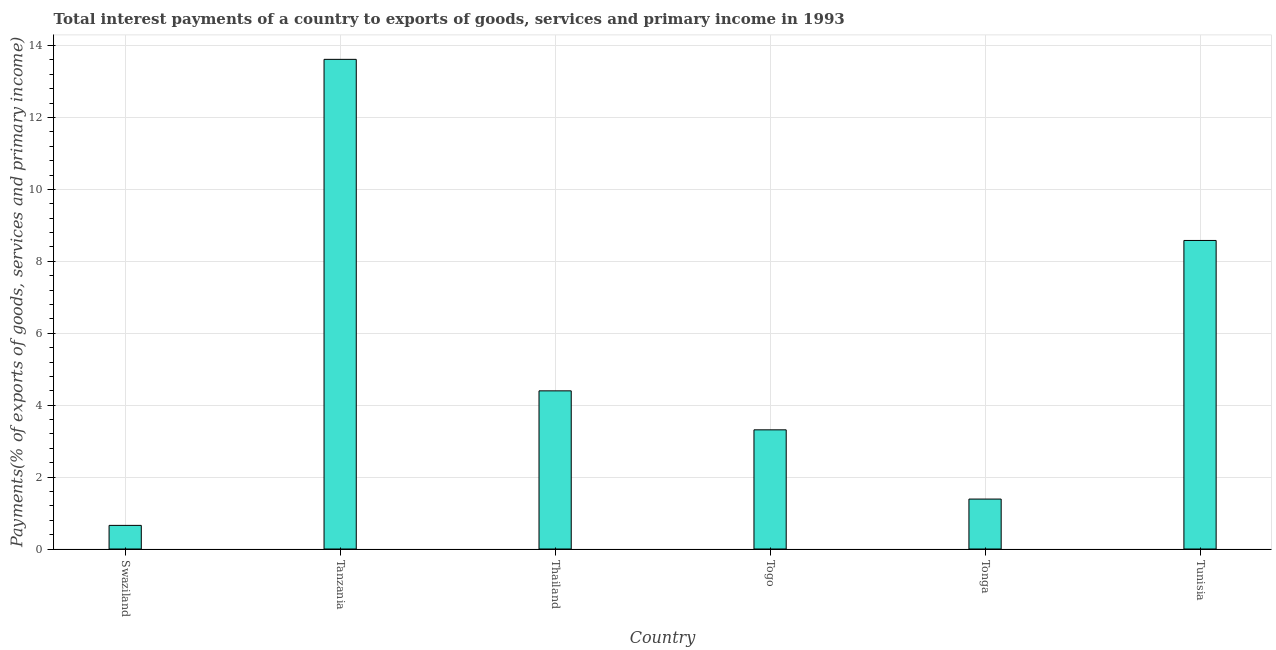Does the graph contain grids?
Keep it short and to the point. Yes. What is the title of the graph?
Offer a very short reply. Total interest payments of a country to exports of goods, services and primary income in 1993. What is the label or title of the X-axis?
Make the answer very short. Country. What is the label or title of the Y-axis?
Offer a very short reply. Payments(% of exports of goods, services and primary income). What is the total interest payments on external debt in Tanzania?
Keep it short and to the point. 13.62. Across all countries, what is the maximum total interest payments on external debt?
Provide a short and direct response. 13.62. Across all countries, what is the minimum total interest payments on external debt?
Ensure brevity in your answer.  0.66. In which country was the total interest payments on external debt maximum?
Offer a very short reply. Tanzania. In which country was the total interest payments on external debt minimum?
Make the answer very short. Swaziland. What is the sum of the total interest payments on external debt?
Your answer should be compact. 31.96. What is the difference between the total interest payments on external debt in Togo and Tonga?
Offer a very short reply. 1.93. What is the average total interest payments on external debt per country?
Give a very brief answer. 5.33. What is the median total interest payments on external debt?
Give a very brief answer. 3.86. What is the ratio of the total interest payments on external debt in Swaziland to that in Tunisia?
Keep it short and to the point. 0.08. Is the difference between the total interest payments on external debt in Swaziland and Tonga greater than the difference between any two countries?
Provide a succinct answer. No. What is the difference between the highest and the second highest total interest payments on external debt?
Ensure brevity in your answer.  5.04. What is the difference between the highest and the lowest total interest payments on external debt?
Offer a very short reply. 12.96. How many bars are there?
Your response must be concise. 6. How many countries are there in the graph?
Your response must be concise. 6. What is the difference between two consecutive major ticks on the Y-axis?
Provide a short and direct response. 2. Are the values on the major ticks of Y-axis written in scientific E-notation?
Make the answer very short. No. What is the Payments(% of exports of goods, services and primary income) in Swaziland?
Give a very brief answer. 0.66. What is the Payments(% of exports of goods, services and primary income) of Tanzania?
Offer a very short reply. 13.62. What is the Payments(% of exports of goods, services and primary income) in Thailand?
Your answer should be very brief. 4.4. What is the Payments(% of exports of goods, services and primary income) in Togo?
Provide a succinct answer. 3.31. What is the Payments(% of exports of goods, services and primary income) in Tonga?
Give a very brief answer. 1.39. What is the Payments(% of exports of goods, services and primary income) in Tunisia?
Your response must be concise. 8.58. What is the difference between the Payments(% of exports of goods, services and primary income) in Swaziland and Tanzania?
Keep it short and to the point. -12.96. What is the difference between the Payments(% of exports of goods, services and primary income) in Swaziland and Thailand?
Provide a short and direct response. -3.74. What is the difference between the Payments(% of exports of goods, services and primary income) in Swaziland and Togo?
Provide a short and direct response. -2.66. What is the difference between the Payments(% of exports of goods, services and primary income) in Swaziland and Tonga?
Provide a short and direct response. -0.73. What is the difference between the Payments(% of exports of goods, services and primary income) in Swaziland and Tunisia?
Provide a short and direct response. -7.92. What is the difference between the Payments(% of exports of goods, services and primary income) in Tanzania and Thailand?
Your response must be concise. 9.22. What is the difference between the Payments(% of exports of goods, services and primary income) in Tanzania and Togo?
Your response must be concise. 10.3. What is the difference between the Payments(% of exports of goods, services and primary income) in Tanzania and Tonga?
Offer a very short reply. 12.23. What is the difference between the Payments(% of exports of goods, services and primary income) in Tanzania and Tunisia?
Offer a very short reply. 5.04. What is the difference between the Payments(% of exports of goods, services and primary income) in Thailand and Togo?
Give a very brief answer. 1.08. What is the difference between the Payments(% of exports of goods, services and primary income) in Thailand and Tonga?
Ensure brevity in your answer.  3.01. What is the difference between the Payments(% of exports of goods, services and primary income) in Thailand and Tunisia?
Offer a terse response. -4.18. What is the difference between the Payments(% of exports of goods, services and primary income) in Togo and Tonga?
Ensure brevity in your answer.  1.93. What is the difference between the Payments(% of exports of goods, services and primary income) in Togo and Tunisia?
Keep it short and to the point. -5.27. What is the difference between the Payments(% of exports of goods, services and primary income) in Tonga and Tunisia?
Your response must be concise. -7.19. What is the ratio of the Payments(% of exports of goods, services and primary income) in Swaziland to that in Tanzania?
Make the answer very short. 0.05. What is the ratio of the Payments(% of exports of goods, services and primary income) in Swaziland to that in Thailand?
Give a very brief answer. 0.15. What is the ratio of the Payments(% of exports of goods, services and primary income) in Swaziland to that in Togo?
Offer a terse response. 0.2. What is the ratio of the Payments(% of exports of goods, services and primary income) in Swaziland to that in Tonga?
Offer a very short reply. 0.47. What is the ratio of the Payments(% of exports of goods, services and primary income) in Swaziland to that in Tunisia?
Provide a short and direct response. 0.08. What is the ratio of the Payments(% of exports of goods, services and primary income) in Tanzania to that in Thailand?
Ensure brevity in your answer.  3.1. What is the ratio of the Payments(% of exports of goods, services and primary income) in Tanzania to that in Togo?
Offer a very short reply. 4.11. What is the ratio of the Payments(% of exports of goods, services and primary income) in Tanzania to that in Tonga?
Keep it short and to the point. 9.81. What is the ratio of the Payments(% of exports of goods, services and primary income) in Tanzania to that in Tunisia?
Your answer should be compact. 1.59. What is the ratio of the Payments(% of exports of goods, services and primary income) in Thailand to that in Togo?
Your answer should be very brief. 1.33. What is the ratio of the Payments(% of exports of goods, services and primary income) in Thailand to that in Tonga?
Offer a terse response. 3.17. What is the ratio of the Payments(% of exports of goods, services and primary income) in Thailand to that in Tunisia?
Give a very brief answer. 0.51. What is the ratio of the Payments(% of exports of goods, services and primary income) in Togo to that in Tonga?
Your response must be concise. 2.39. What is the ratio of the Payments(% of exports of goods, services and primary income) in Togo to that in Tunisia?
Your answer should be compact. 0.39. What is the ratio of the Payments(% of exports of goods, services and primary income) in Tonga to that in Tunisia?
Provide a short and direct response. 0.16. 